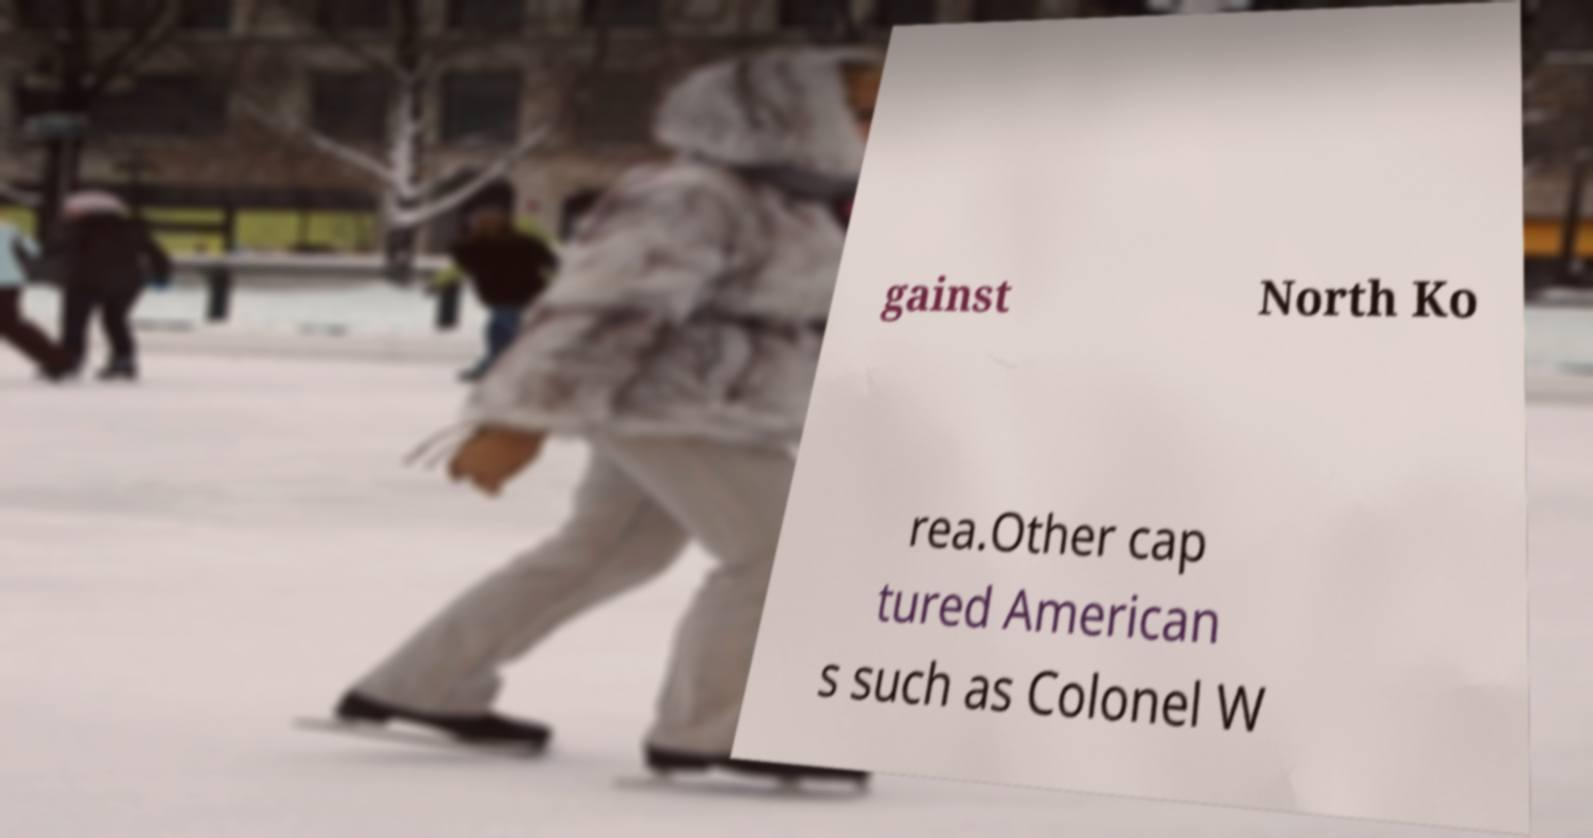There's text embedded in this image that I need extracted. Can you transcribe it verbatim? gainst North Ko rea.Other cap tured American s such as Colonel W 